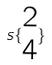<formula> <loc_0><loc_0><loc_500><loc_500>s \{ \begin{matrix} 2 \\ 4 \end{matrix} \}</formula> 